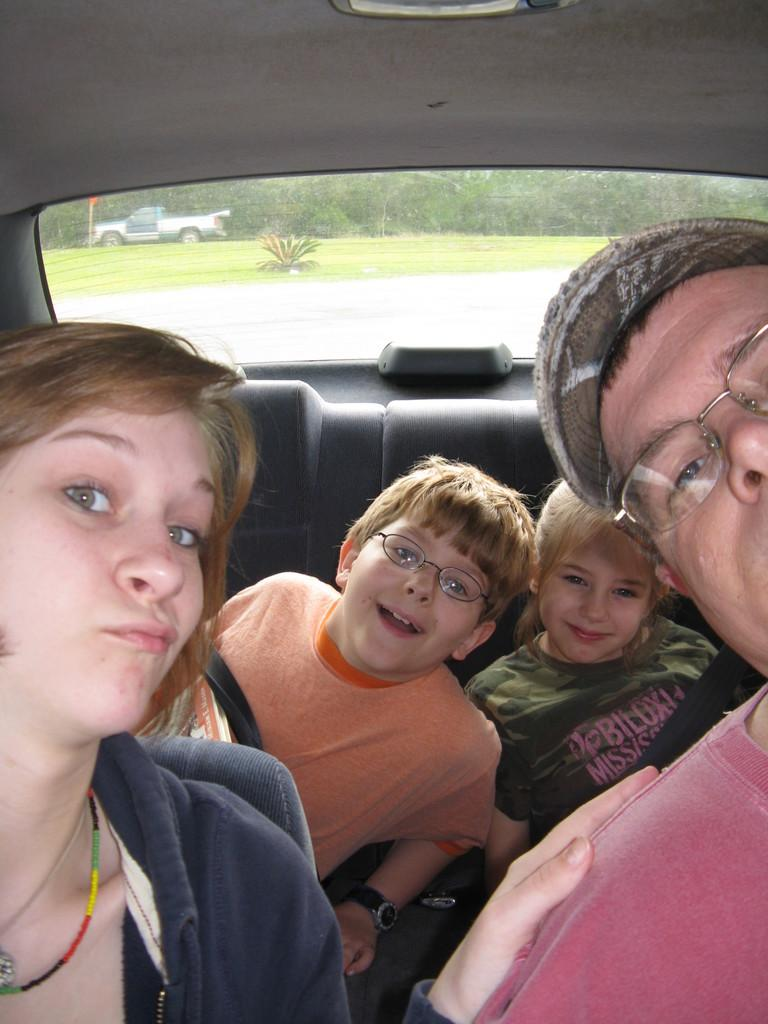How many people are in the image? There are four people in the image: a woman, a man, and two children. What are the people doing in the image? The people are in a car. What can be seen in the background of the image? There is a tree and a road in the background of the image. What type of net is being used to catch the pig in the image? There is no pig or net present in the image. What kind of structure is visible in the background of the image? The image does not show any structures in the background; it only shows a tree and a road. 